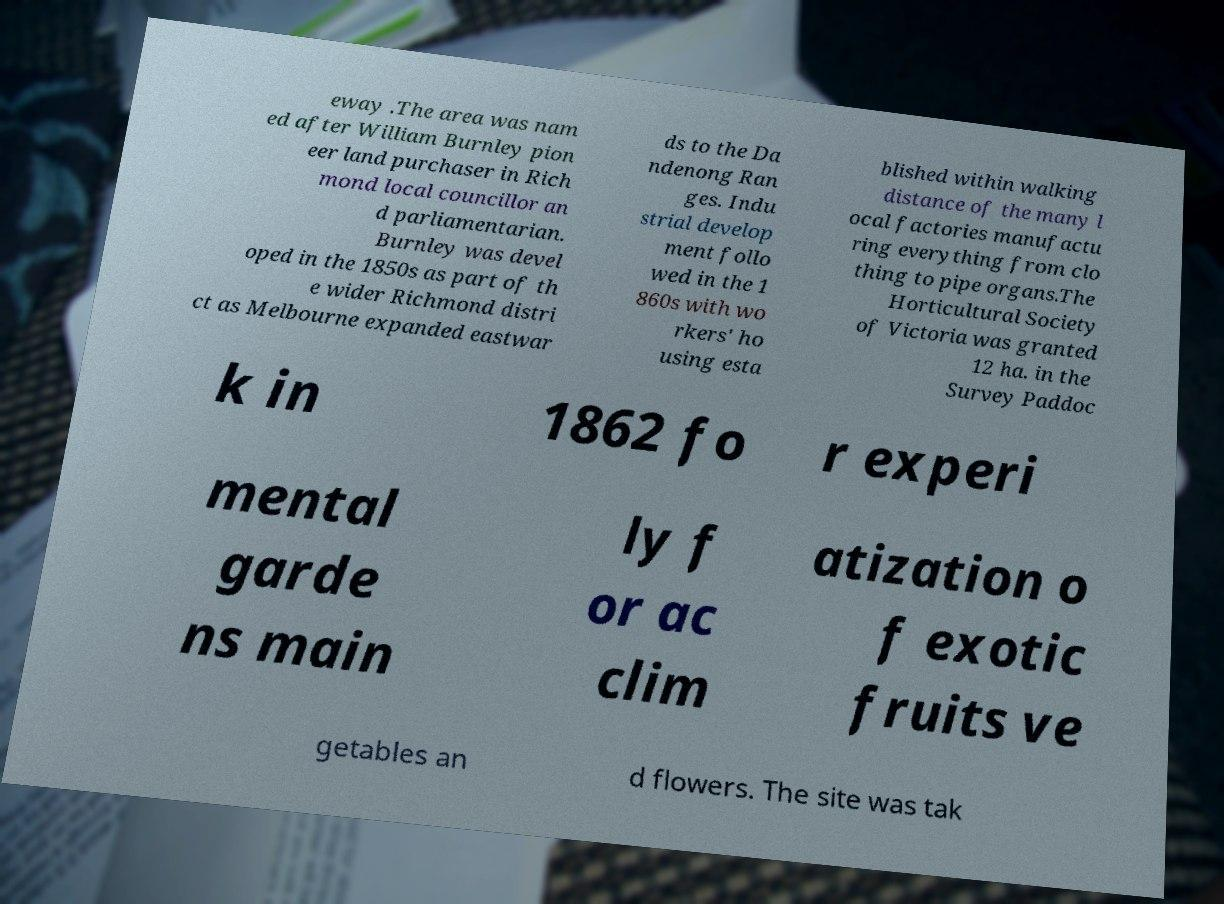Can you accurately transcribe the text from the provided image for me? eway .The area was nam ed after William Burnley pion eer land purchaser in Rich mond local councillor an d parliamentarian. Burnley was devel oped in the 1850s as part of th e wider Richmond distri ct as Melbourne expanded eastwar ds to the Da ndenong Ran ges. Indu strial develop ment follo wed in the 1 860s with wo rkers' ho using esta blished within walking distance of the many l ocal factories manufactu ring everything from clo thing to pipe organs.The Horticultural Society of Victoria was granted 12 ha. in the Survey Paddoc k in 1862 fo r experi mental garde ns main ly f or ac clim atization o f exotic fruits ve getables an d flowers. The site was tak 